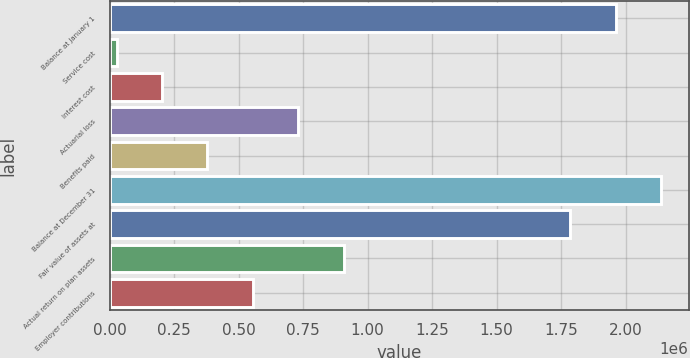<chart> <loc_0><loc_0><loc_500><loc_500><bar_chart><fcel>Balance at January 1<fcel>Service cost<fcel>Interest cost<fcel>Actuarial loss<fcel>Benefits paid<fcel>Balance at December 31<fcel>Fair value of assets at<fcel>Actual return on plan assets<fcel>Employer contributions<nl><fcel>1.9615e+06<fcel>27698<fcel>203498<fcel>730899<fcel>379298<fcel>2.1373e+06<fcel>1.7857e+06<fcel>906699<fcel>555099<nl></chart> 